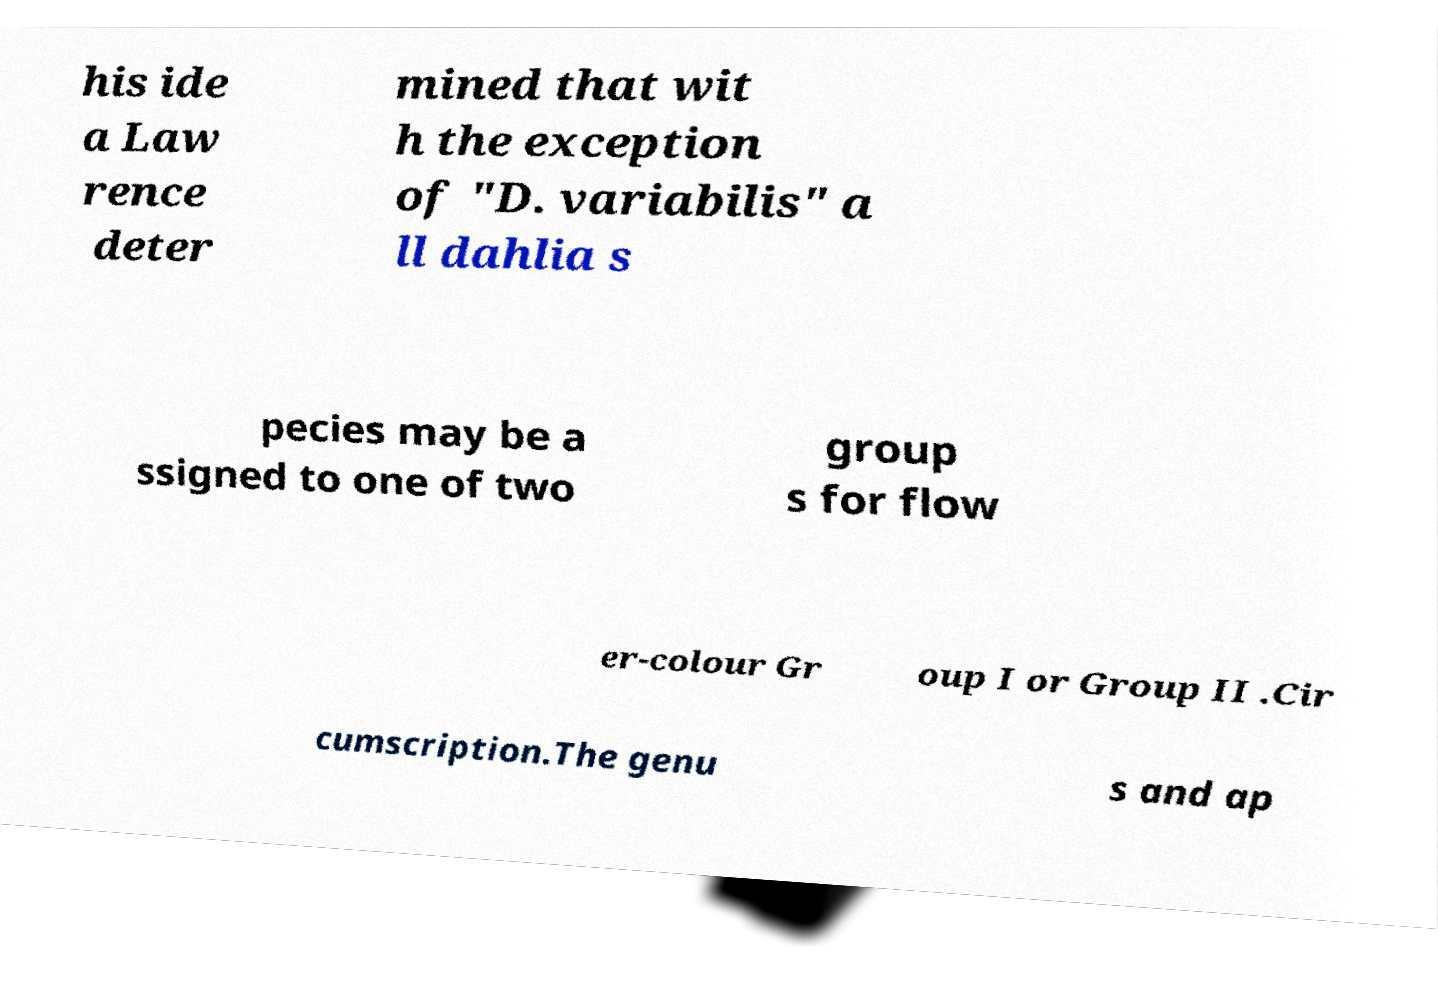Could you extract and type out the text from this image? his ide a Law rence deter mined that wit h the exception of "D. variabilis" a ll dahlia s pecies may be a ssigned to one of two group s for flow er-colour Gr oup I or Group II .Cir cumscription.The genu s and ap 